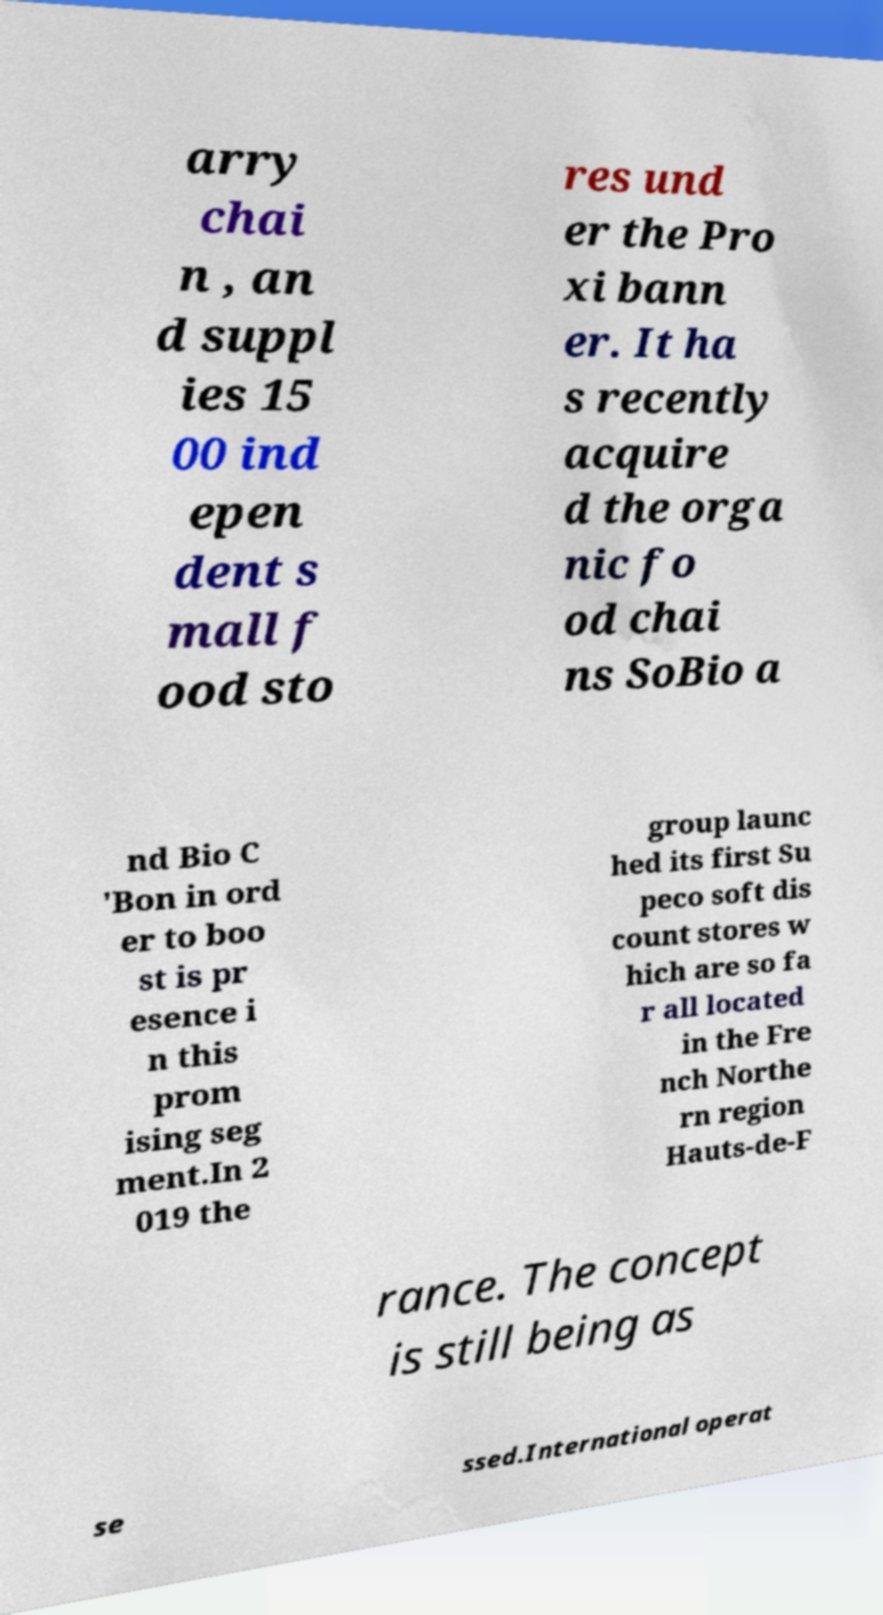Please identify and transcribe the text found in this image. arry chai n , an d suppl ies 15 00 ind epen dent s mall f ood sto res und er the Pro xi bann er. It ha s recently acquire d the orga nic fo od chai ns SoBio a nd Bio C 'Bon in ord er to boo st is pr esence i n this prom ising seg ment.In 2 019 the group launc hed its first Su peco soft dis count stores w hich are so fa r all located in the Fre nch Northe rn region Hauts-de-F rance. The concept is still being as se ssed.International operat 